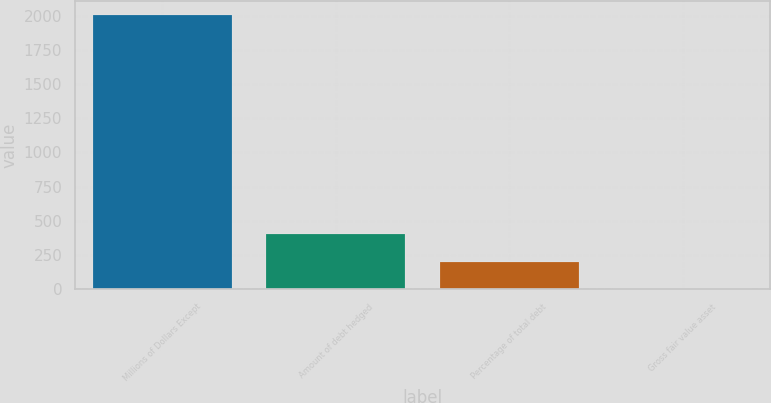<chart> <loc_0><loc_0><loc_500><loc_500><bar_chart><fcel>Millions of Dollars Except<fcel>Amount of debt hedged<fcel>Percentage of total debt<fcel>Gross fair value asset<nl><fcel>2007<fcel>403<fcel>202.5<fcel>2<nl></chart> 